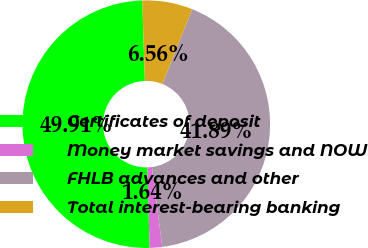<chart> <loc_0><loc_0><loc_500><loc_500><pie_chart><fcel>Certificates of deposit<fcel>Money market savings and NOW<fcel>FHLB advances and other<fcel>Total interest-bearing banking<nl><fcel>49.91%<fcel>1.64%<fcel>41.89%<fcel>6.56%<nl></chart> 